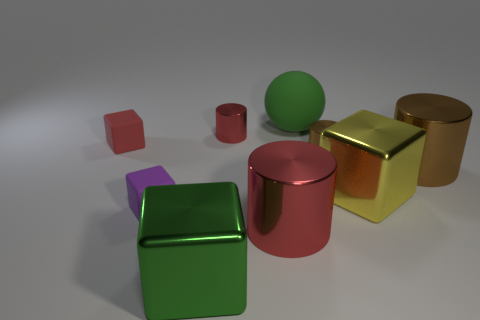Is there a tiny rubber block that is behind the small red thing that is on the left side of the large metallic cube in front of the purple rubber thing?
Ensure brevity in your answer.  No. There is another matte thing that is the same size as the purple matte thing; what is its shape?
Give a very brief answer. Cube. There is a metal block right of the small red metallic thing; does it have the same size as the cylinder in front of the small purple object?
Keep it short and to the point. Yes. What number of big shiny things are there?
Your answer should be very brief. 4. There is a green thing that is in front of the rubber thing that is right of the red shiny thing in front of the tiny red cylinder; how big is it?
Ensure brevity in your answer.  Large. Are there any other things that have the same size as the green metallic object?
Your answer should be very brief. Yes. What number of large rubber things are to the left of the purple thing?
Offer a terse response. 0. Are there an equal number of green rubber things that are in front of the tiny red matte object and purple blocks?
Your response must be concise. No. How many objects are large gray rubber cylinders or tiny rubber things?
Offer a very short reply. 2. Are there any other things that have the same shape as the big yellow metal object?
Ensure brevity in your answer.  Yes. 